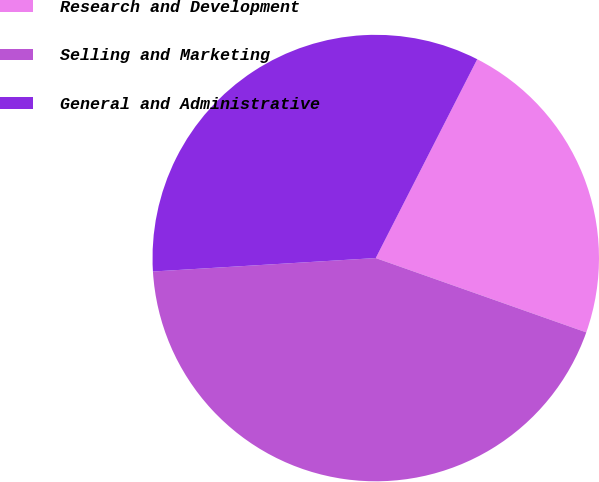<chart> <loc_0><loc_0><loc_500><loc_500><pie_chart><fcel>Research and Development<fcel>Selling and Marketing<fcel>General and Administrative<nl><fcel>22.89%<fcel>43.64%<fcel>33.47%<nl></chart> 